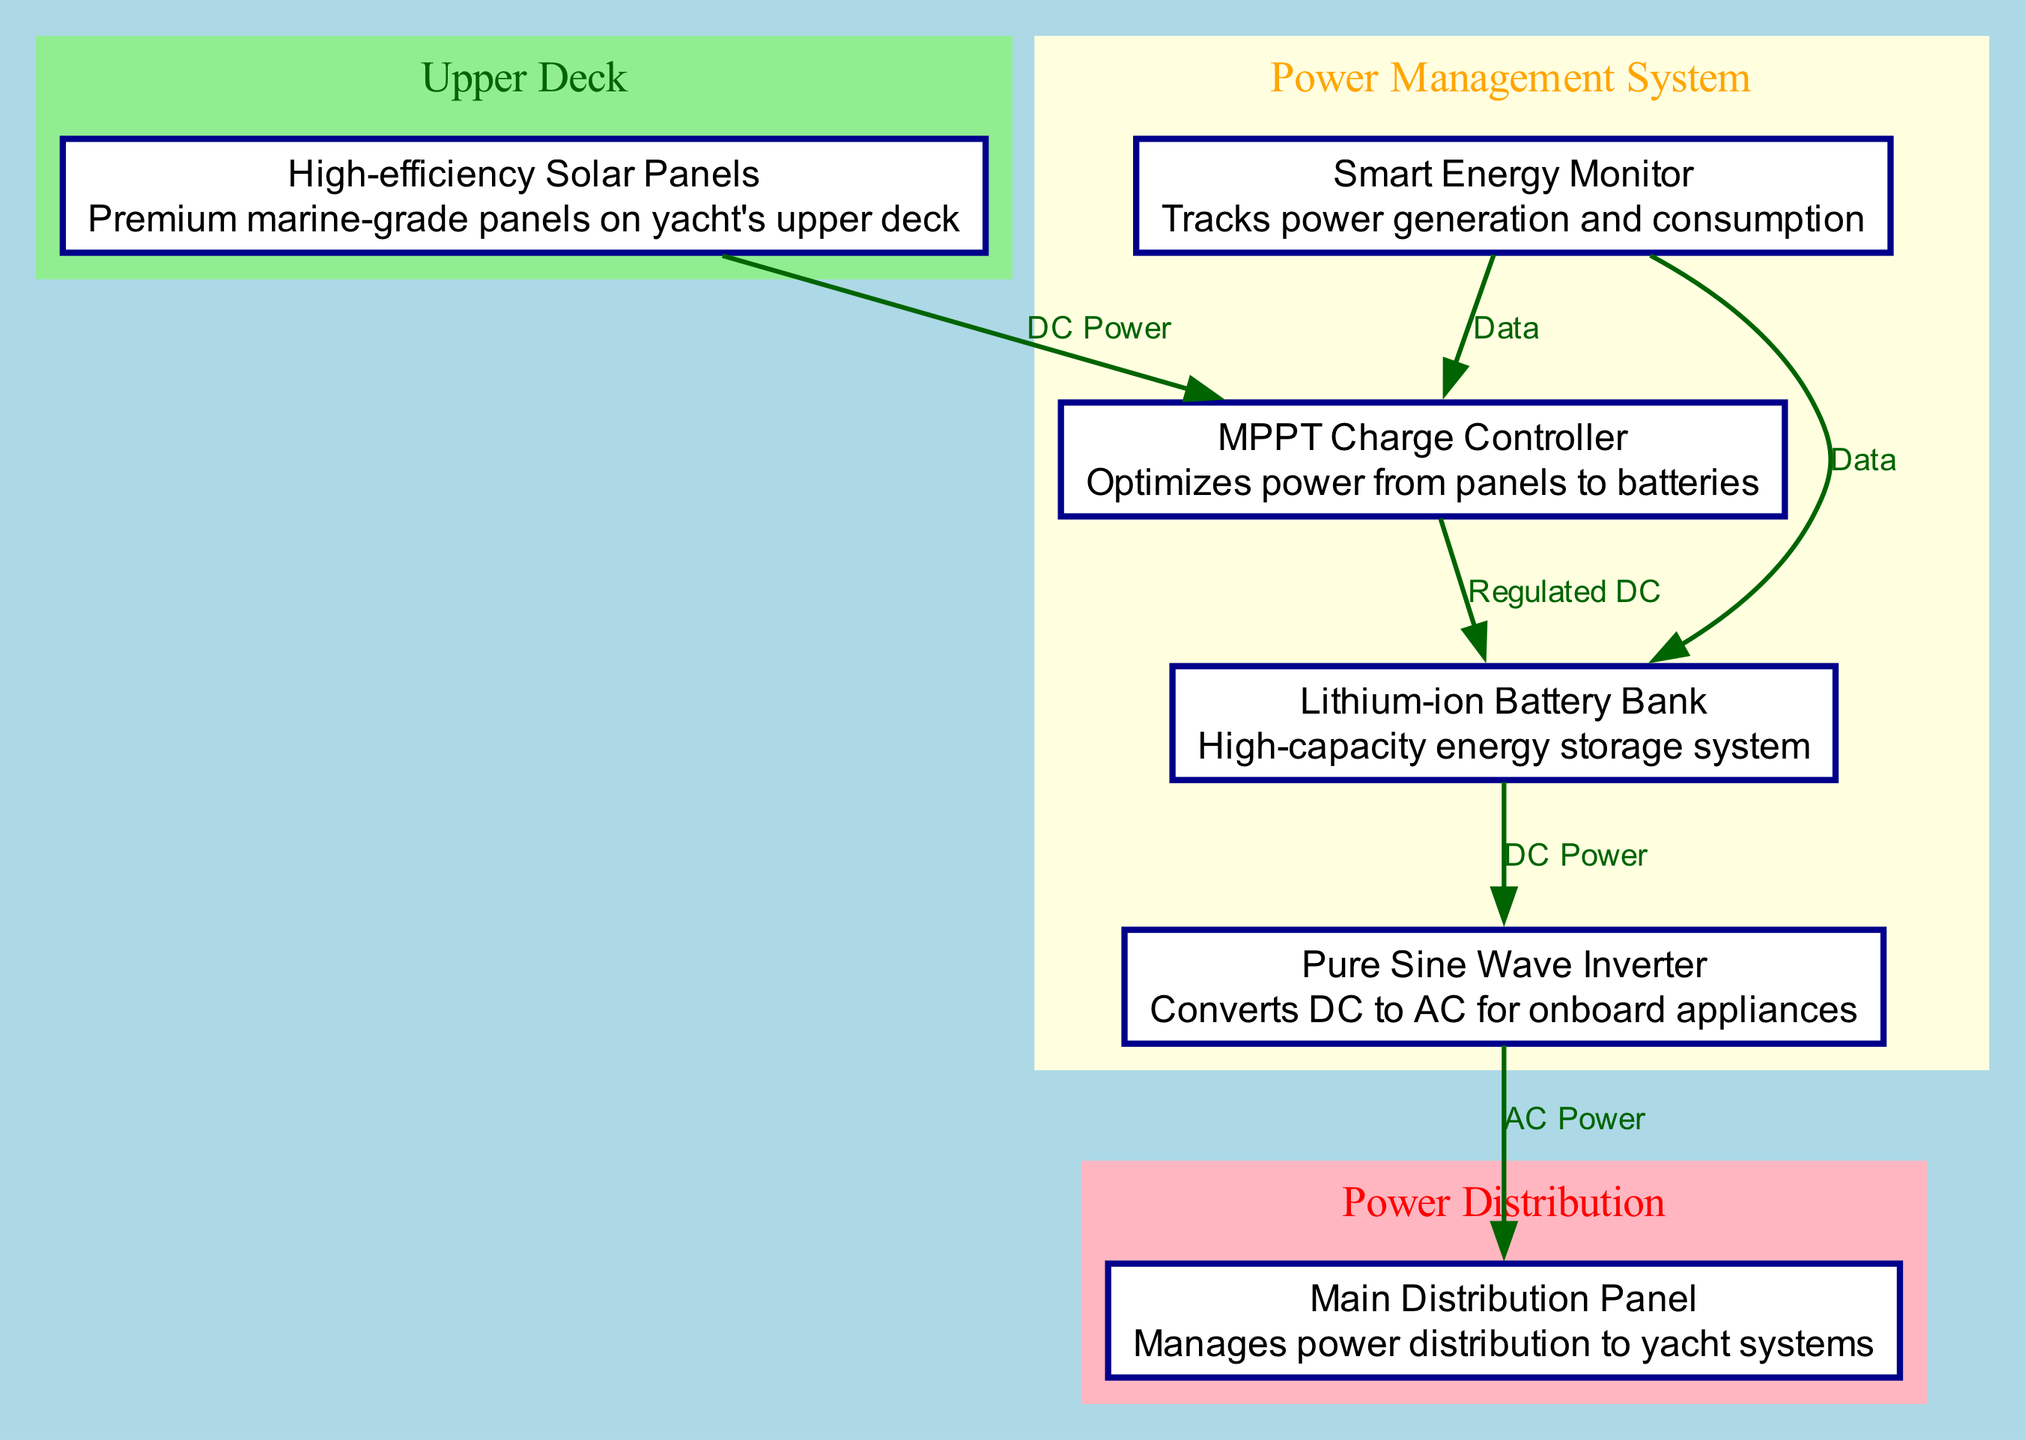What is the energy storage solution used in the system? The diagram identifies the "Lithium-ion Battery Bank" as the energy storage solution, which is categorized under "High-capacity energy storage system."
Answer: Lithium-ion Battery Bank How many components are in the power management system? By examining the diagram, there are four components listed in the "Power Management System": MPPT Charge Controller, Lithium-ion Battery Bank, Pure Sine Wave Inverter, and Smart Energy Monitor.
Answer: Four What type of power does the inverter convert? The diagram specifies that the Pure Sine Wave Inverter converts "DC to AC," indicating the type of power conversion it performs.
Answer: DC to AC What manages power distribution to yacht systems? The diagram shows that the "Main Distribution Panel" manages power distribution, as it is the final component in the power flow sequence.
Answer: Main Distribution Panel What is the role of the Smart Energy Monitor? The diagram points out that the Smart Energy Monitor "Tracks power generation and consumption," showcasing its role in the system.
Answer: Tracks power generation and consumption Describe the flow of power from the solar panels to the lithium batteries. According to the diagram, power flows as follows: "High-efficiency Solar Panels" produce DC power, which goes to the "MPPT Charge Controller," and then the controller sends regulated DC to the "Lithium-ion Battery Bank."
Answer: Solar Panels → Charge Controller → Lithium-ion Batteries Which component is responsible for optimizing power from the panels? The diagram identifies the "MPPT Charge Controller" as the component responsible for optimizing power from the solar panels to the batteries.
Answer: MPPT Charge Controller How does the system track data related to power usage? The diagram indicates that the "Smart Energy Monitor" sends data to both the "MPPT Charge Controller" and the "Lithium-ion Battery Bank," demonstrating its role in tracking power usage.
Answer: Smart Energy Monitor What is placed on the yacht's upper deck? The diagram specifically labels the "High-efficiency Solar Panels" as being placed on the yacht's upper deck, denoting their location.
Answer: High-efficiency Solar Panels 